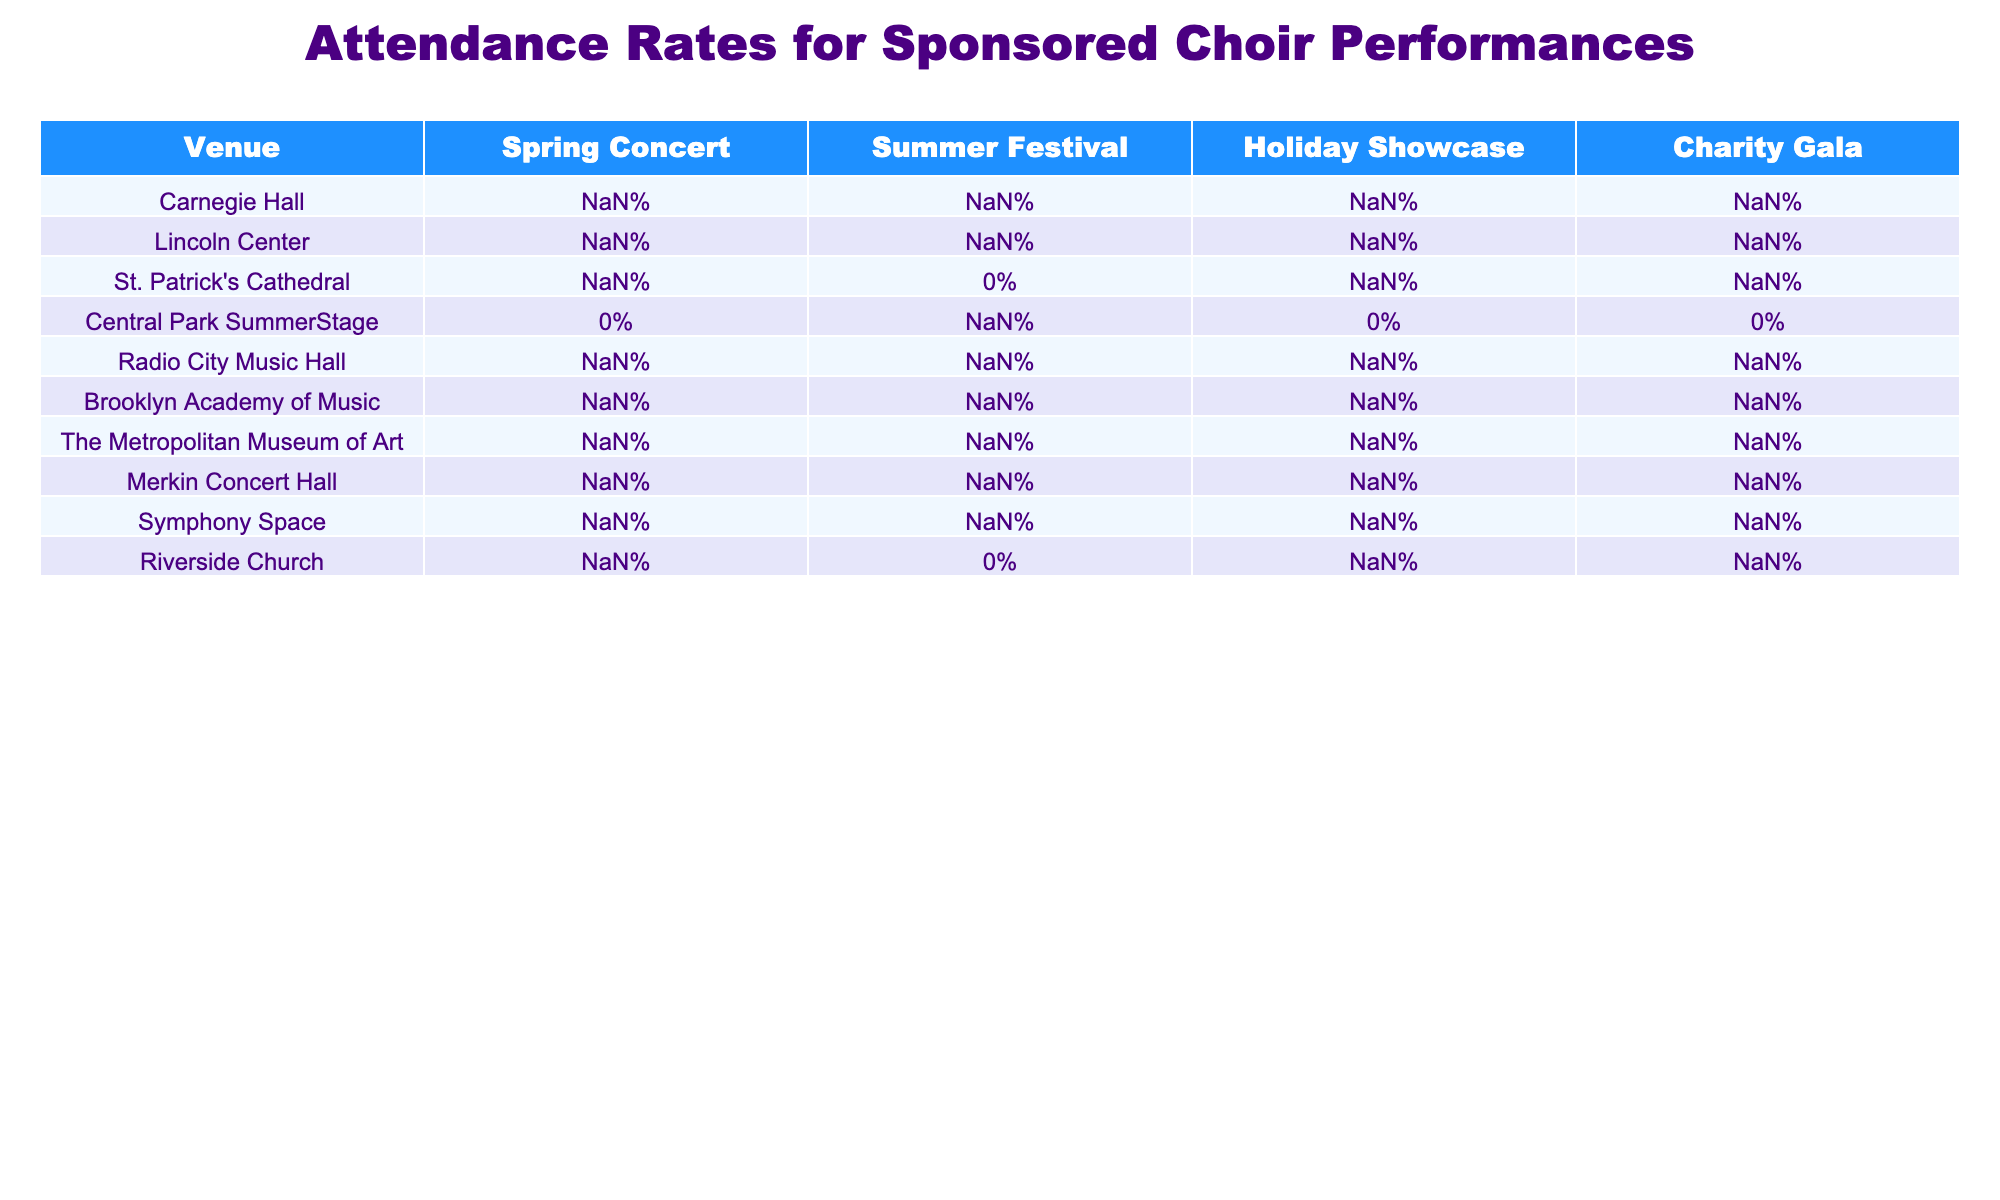What was the attendance rate for the Spring Concert at Carnegie Hall? The table shows that the attendance rate for the Spring Concert at Carnegie Hall is 92%.
Answer: 92% Which venue had the highest attendance rate for the Holiday Showcase? By inspecting the table, St. Patrick's Cathedral has the highest attendance rate for the Holiday Showcase at 98%.
Answer: St. Patrick's Cathedral What is the average attendance rate for the Summer Festival across all venues that participated? The venues with attendance rates for the Summer Festival are Carnegie Hall (88%), Lincoln Center (85%), St. Patrick's Cathedral (N/A), Central Park SummerStage (97%), Radio City Music Hall (86%), Brooklyn Academy of Music (83%), The Metropolitan Museum of Art (89%), Merkin Concert Hall (81%), Symphony Space (80%), and Riverside Church (N/A). Ignoring N/A values, the sum is (88 + 85 + 97 + 86 + 83 + 89 + 81 + 80) =  43 + 97 + 85 + 89 + 86 + 81 + 80 = 500, and there are 8 valid entries, resulting in an average attendance rate of 500/8 = 87.5%.
Answer: 87.5% Did Central Park SummerStage have an attendance rate for the Charity Gala? The table indicates that Central Park SummerStage does not have a recorded attendance rate for the Charity Gala (N/A).
Answer: No What are the attendance rates for Riverside Church for all events listed? Looking at the table, Riverside Church has attendance rates of 94% for the Spring Concert, N/A for the Summer Festival, 96% for the Holiday Showcase, and 90% for the Charity Gala.
Answer: 94%, N/A, 96%, 90% Which venue had a consistent attendance rate of 90% or above for the performances listed? Examining the table, Carnegie Hall maintained a performance attendance rate of 92%, 88%, 95%, and 97%, which includes both 90% and above; St. Patrick's Cathedral also hit these marks with 96% and 98%. Thus, Carnegie Hall and St. Patrick's Cathedral can be identified as venues with a consistent attendance of at least 90%.
Answer: Carnegie Hall and St. Patrick's Cathedral Which venue has the lowest attendance rate across all events? The lowest attendance rate can be determined by reviewing each performance: looking at the values, the lowest is from Symphony Space at 80% for the Summer Festival.
Answer: Symphony Space What is the difference in attendance rates for the Spring Concert between Lincoln Center and Brooklyn Academy of Music? The Spring Concert attendance at Lincoln Center is 89%, and at Brooklyn Academy of Music, it is 87%. The difference is 89% - 87% = 2%.
Answer: 2% How many venues have an N/A attendance rate in the Summer Festival? The review of the Summer Festival column reveals that two venues, St. Patrick's Cathedral and Riverside Church, have N/A attendance rates.
Answer: 2 